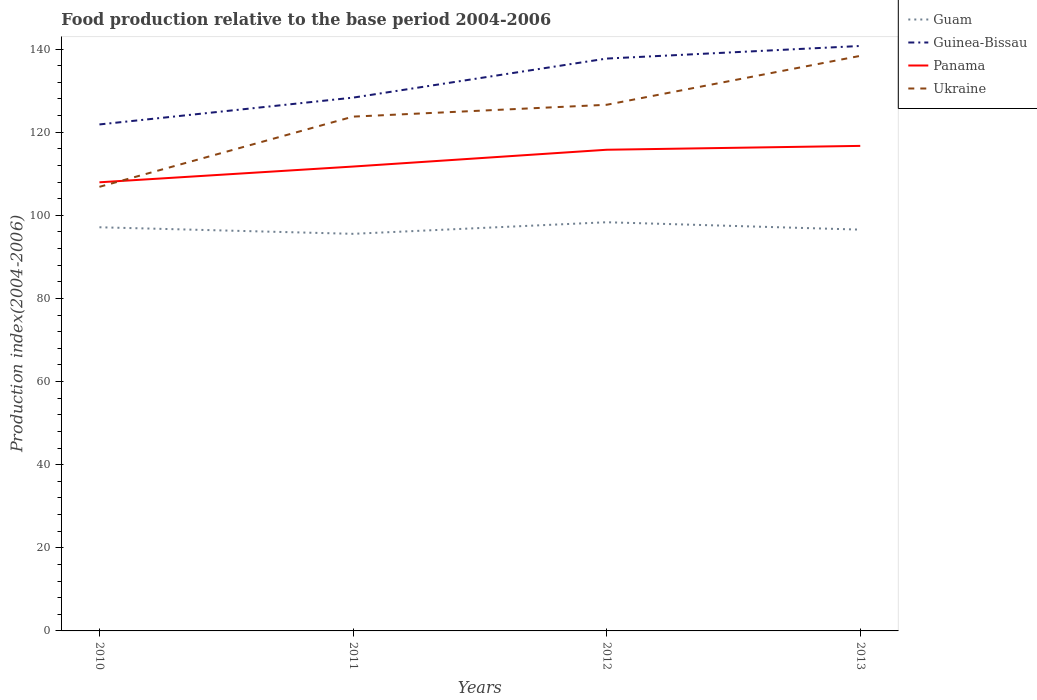Does the line corresponding to Guam intersect with the line corresponding to Ukraine?
Keep it short and to the point. No. Is the number of lines equal to the number of legend labels?
Your answer should be very brief. Yes. Across all years, what is the maximum food production index in Ukraine?
Provide a short and direct response. 106.85. What is the total food production index in Guam in the graph?
Your response must be concise. -2.79. What is the difference between the highest and the second highest food production index in Guam?
Provide a succinct answer. 2.79. What is the difference between the highest and the lowest food production index in Guinea-Bissau?
Your answer should be very brief. 2. How many years are there in the graph?
Provide a short and direct response. 4. What is the title of the graph?
Your response must be concise. Food production relative to the base period 2004-2006. Does "Kuwait" appear as one of the legend labels in the graph?
Give a very brief answer. No. What is the label or title of the X-axis?
Ensure brevity in your answer.  Years. What is the label or title of the Y-axis?
Your answer should be compact. Production index(2004-2006). What is the Production index(2004-2006) in Guam in 2010?
Offer a very short reply. 97.12. What is the Production index(2004-2006) of Guinea-Bissau in 2010?
Your answer should be compact. 121.86. What is the Production index(2004-2006) in Panama in 2010?
Provide a succinct answer. 107.94. What is the Production index(2004-2006) in Ukraine in 2010?
Provide a short and direct response. 106.85. What is the Production index(2004-2006) in Guam in 2011?
Make the answer very short. 95.54. What is the Production index(2004-2006) of Guinea-Bissau in 2011?
Your answer should be compact. 128.31. What is the Production index(2004-2006) of Panama in 2011?
Ensure brevity in your answer.  111.73. What is the Production index(2004-2006) of Ukraine in 2011?
Make the answer very short. 123.74. What is the Production index(2004-2006) of Guam in 2012?
Give a very brief answer. 98.33. What is the Production index(2004-2006) of Guinea-Bissau in 2012?
Provide a succinct answer. 137.71. What is the Production index(2004-2006) of Panama in 2012?
Make the answer very short. 115.77. What is the Production index(2004-2006) of Ukraine in 2012?
Offer a terse response. 126.59. What is the Production index(2004-2006) in Guam in 2013?
Offer a terse response. 96.55. What is the Production index(2004-2006) in Guinea-Bissau in 2013?
Your answer should be compact. 140.74. What is the Production index(2004-2006) of Panama in 2013?
Keep it short and to the point. 116.7. What is the Production index(2004-2006) of Ukraine in 2013?
Your response must be concise. 138.36. Across all years, what is the maximum Production index(2004-2006) in Guam?
Offer a very short reply. 98.33. Across all years, what is the maximum Production index(2004-2006) of Guinea-Bissau?
Keep it short and to the point. 140.74. Across all years, what is the maximum Production index(2004-2006) of Panama?
Your answer should be compact. 116.7. Across all years, what is the maximum Production index(2004-2006) in Ukraine?
Your answer should be very brief. 138.36. Across all years, what is the minimum Production index(2004-2006) in Guam?
Provide a short and direct response. 95.54. Across all years, what is the minimum Production index(2004-2006) of Guinea-Bissau?
Keep it short and to the point. 121.86. Across all years, what is the minimum Production index(2004-2006) in Panama?
Your response must be concise. 107.94. Across all years, what is the minimum Production index(2004-2006) in Ukraine?
Provide a succinct answer. 106.85. What is the total Production index(2004-2006) of Guam in the graph?
Offer a terse response. 387.54. What is the total Production index(2004-2006) of Guinea-Bissau in the graph?
Provide a succinct answer. 528.62. What is the total Production index(2004-2006) in Panama in the graph?
Your response must be concise. 452.14. What is the total Production index(2004-2006) in Ukraine in the graph?
Offer a very short reply. 495.54. What is the difference between the Production index(2004-2006) of Guam in 2010 and that in 2011?
Make the answer very short. 1.58. What is the difference between the Production index(2004-2006) in Guinea-Bissau in 2010 and that in 2011?
Offer a terse response. -6.45. What is the difference between the Production index(2004-2006) in Panama in 2010 and that in 2011?
Offer a terse response. -3.79. What is the difference between the Production index(2004-2006) of Ukraine in 2010 and that in 2011?
Offer a very short reply. -16.89. What is the difference between the Production index(2004-2006) of Guam in 2010 and that in 2012?
Provide a short and direct response. -1.21. What is the difference between the Production index(2004-2006) of Guinea-Bissau in 2010 and that in 2012?
Your answer should be very brief. -15.85. What is the difference between the Production index(2004-2006) of Panama in 2010 and that in 2012?
Ensure brevity in your answer.  -7.83. What is the difference between the Production index(2004-2006) in Ukraine in 2010 and that in 2012?
Keep it short and to the point. -19.74. What is the difference between the Production index(2004-2006) of Guam in 2010 and that in 2013?
Provide a succinct answer. 0.57. What is the difference between the Production index(2004-2006) of Guinea-Bissau in 2010 and that in 2013?
Your answer should be very brief. -18.88. What is the difference between the Production index(2004-2006) of Panama in 2010 and that in 2013?
Provide a succinct answer. -8.76. What is the difference between the Production index(2004-2006) of Ukraine in 2010 and that in 2013?
Keep it short and to the point. -31.51. What is the difference between the Production index(2004-2006) of Guam in 2011 and that in 2012?
Keep it short and to the point. -2.79. What is the difference between the Production index(2004-2006) in Guinea-Bissau in 2011 and that in 2012?
Give a very brief answer. -9.4. What is the difference between the Production index(2004-2006) in Panama in 2011 and that in 2012?
Offer a terse response. -4.04. What is the difference between the Production index(2004-2006) in Ukraine in 2011 and that in 2012?
Offer a very short reply. -2.85. What is the difference between the Production index(2004-2006) in Guam in 2011 and that in 2013?
Your response must be concise. -1.01. What is the difference between the Production index(2004-2006) in Guinea-Bissau in 2011 and that in 2013?
Your response must be concise. -12.43. What is the difference between the Production index(2004-2006) in Panama in 2011 and that in 2013?
Keep it short and to the point. -4.97. What is the difference between the Production index(2004-2006) in Ukraine in 2011 and that in 2013?
Your answer should be compact. -14.62. What is the difference between the Production index(2004-2006) in Guam in 2012 and that in 2013?
Your response must be concise. 1.78. What is the difference between the Production index(2004-2006) of Guinea-Bissau in 2012 and that in 2013?
Offer a very short reply. -3.03. What is the difference between the Production index(2004-2006) in Panama in 2012 and that in 2013?
Offer a very short reply. -0.93. What is the difference between the Production index(2004-2006) of Ukraine in 2012 and that in 2013?
Your answer should be compact. -11.77. What is the difference between the Production index(2004-2006) in Guam in 2010 and the Production index(2004-2006) in Guinea-Bissau in 2011?
Offer a terse response. -31.19. What is the difference between the Production index(2004-2006) in Guam in 2010 and the Production index(2004-2006) in Panama in 2011?
Offer a terse response. -14.61. What is the difference between the Production index(2004-2006) of Guam in 2010 and the Production index(2004-2006) of Ukraine in 2011?
Your answer should be very brief. -26.62. What is the difference between the Production index(2004-2006) of Guinea-Bissau in 2010 and the Production index(2004-2006) of Panama in 2011?
Give a very brief answer. 10.13. What is the difference between the Production index(2004-2006) of Guinea-Bissau in 2010 and the Production index(2004-2006) of Ukraine in 2011?
Provide a short and direct response. -1.88. What is the difference between the Production index(2004-2006) in Panama in 2010 and the Production index(2004-2006) in Ukraine in 2011?
Provide a succinct answer. -15.8. What is the difference between the Production index(2004-2006) of Guam in 2010 and the Production index(2004-2006) of Guinea-Bissau in 2012?
Give a very brief answer. -40.59. What is the difference between the Production index(2004-2006) in Guam in 2010 and the Production index(2004-2006) in Panama in 2012?
Your answer should be compact. -18.65. What is the difference between the Production index(2004-2006) in Guam in 2010 and the Production index(2004-2006) in Ukraine in 2012?
Give a very brief answer. -29.47. What is the difference between the Production index(2004-2006) in Guinea-Bissau in 2010 and the Production index(2004-2006) in Panama in 2012?
Offer a terse response. 6.09. What is the difference between the Production index(2004-2006) of Guinea-Bissau in 2010 and the Production index(2004-2006) of Ukraine in 2012?
Your response must be concise. -4.73. What is the difference between the Production index(2004-2006) in Panama in 2010 and the Production index(2004-2006) in Ukraine in 2012?
Your answer should be very brief. -18.65. What is the difference between the Production index(2004-2006) of Guam in 2010 and the Production index(2004-2006) of Guinea-Bissau in 2013?
Give a very brief answer. -43.62. What is the difference between the Production index(2004-2006) of Guam in 2010 and the Production index(2004-2006) of Panama in 2013?
Offer a terse response. -19.58. What is the difference between the Production index(2004-2006) of Guam in 2010 and the Production index(2004-2006) of Ukraine in 2013?
Make the answer very short. -41.24. What is the difference between the Production index(2004-2006) of Guinea-Bissau in 2010 and the Production index(2004-2006) of Panama in 2013?
Your response must be concise. 5.16. What is the difference between the Production index(2004-2006) of Guinea-Bissau in 2010 and the Production index(2004-2006) of Ukraine in 2013?
Provide a short and direct response. -16.5. What is the difference between the Production index(2004-2006) of Panama in 2010 and the Production index(2004-2006) of Ukraine in 2013?
Provide a succinct answer. -30.42. What is the difference between the Production index(2004-2006) of Guam in 2011 and the Production index(2004-2006) of Guinea-Bissau in 2012?
Ensure brevity in your answer.  -42.17. What is the difference between the Production index(2004-2006) of Guam in 2011 and the Production index(2004-2006) of Panama in 2012?
Provide a short and direct response. -20.23. What is the difference between the Production index(2004-2006) of Guam in 2011 and the Production index(2004-2006) of Ukraine in 2012?
Provide a succinct answer. -31.05. What is the difference between the Production index(2004-2006) of Guinea-Bissau in 2011 and the Production index(2004-2006) of Panama in 2012?
Keep it short and to the point. 12.54. What is the difference between the Production index(2004-2006) in Guinea-Bissau in 2011 and the Production index(2004-2006) in Ukraine in 2012?
Ensure brevity in your answer.  1.72. What is the difference between the Production index(2004-2006) of Panama in 2011 and the Production index(2004-2006) of Ukraine in 2012?
Your response must be concise. -14.86. What is the difference between the Production index(2004-2006) in Guam in 2011 and the Production index(2004-2006) in Guinea-Bissau in 2013?
Your answer should be compact. -45.2. What is the difference between the Production index(2004-2006) of Guam in 2011 and the Production index(2004-2006) of Panama in 2013?
Keep it short and to the point. -21.16. What is the difference between the Production index(2004-2006) of Guam in 2011 and the Production index(2004-2006) of Ukraine in 2013?
Give a very brief answer. -42.82. What is the difference between the Production index(2004-2006) in Guinea-Bissau in 2011 and the Production index(2004-2006) in Panama in 2013?
Your response must be concise. 11.61. What is the difference between the Production index(2004-2006) of Guinea-Bissau in 2011 and the Production index(2004-2006) of Ukraine in 2013?
Give a very brief answer. -10.05. What is the difference between the Production index(2004-2006) of Panama in 2011 and the Production index(2004-2006) of Ukraine in 2013?
Make the answer very short. -26.63. What is the difference between the Production index(2004-2006) in Guam in 2012 and the Production index(2004-2006) in Guinea-Bissau in 2013?
Offer a terse response. -42.41. What is the difference between the Production index(2004-2006) in Guam in 2012 and the Production index(2004-2006) in Panama in 2013?
Ensure brevity in your answer.  -18.37. What is the difference between the Production index(2004-2006) of Guam in 2012 and the Production index(2004-2006) of Ukraine in 2013?
Your answer should be very brief. -40.03. What is the difference between the Production index(2004-2006) in Guinea-Bissau in 2012 and the Production index(2004-2006) in Panama in 2013?
Your answer should be compact. 21.01. What is the difference between the Production index(2004-2006) of Guinea-Bissau in 2012 and the Production index(2004-2006) of Ukraine in 2013?
Offer a terse response. -0.65. What is the difference between the Production index(2004-2006) of Panama in 2012 and the Production index(2004-2006) of Ukraine in 2013?
Provide a succinct answer. -22.59. What is the average Production index(2004-2006) in Guam per year?
Your answer should be very brief. 96.89. What is the average Production index(2004-2006) in Guinea-Bissau per year?
Make the answer very short. 132.16. What is the average Production index(2004-2006) in Panama per year?
Provide a short and direct response. 113.03. What is the average Production index(2004-2006) in Ukraine per year?
Give a very brief answer. 123.89. In the year 2010, what is the difference between the Production index(2004-2006) in Guam and Production index(2004-2006) in Guinea-Bissau?
Provide a short and direct response. -24.74. In the year 2010, what is the difference between the Production index(2004-2006) of Guam and Production index(2004-2006) of Panama?
Provide a short and direct response. -10.82. In the year 2010, what is the difference between the Production index(2004-2006) of Guam and Production index(2004-2006) of Ukraine?
Provide a short and direct response. -9.73. In the year 2010, what is the difference between the Production index(2004-2006) in Guinea-Bissau and Production index(2004-2006) in Panama?
Offer a very short reply. 13.92. In the year 2010, what is the difference between the Production index(2004-2006) in Guinea-Bissau and Production index(2004-2006) in Ukraine?
Your answer should be compact. 15.01. In the year 2010, what is the difference between the Production index(2004-2006) in Panama and Production index(2004-2006) in Ukraine?
Offer a very short reply. 1.09. In the year 2011, what is the difference between the Production index(2004-2006) of Guam and Production index(2004-2006) of Guinea-Bissau?
Keep it short and to the point. -32.77. In the year 2011, what is the difference between the Production index(2004-2006) in Guam and Production index(2004-2006) in Panama?
Give a very brief answer. -16.19. In the year 2011, what is the difference between the Production index(2004-2006) in Guam and Production index(2004-2006) in Ukraine?
Give a very brief answer. -28.2. In the year 2011, what is the difference between the Production index(2004-2006) of Guinea-Bissau and Production index(2004-2006) of Panama?
Keep it short and to the point. 16.58. In the year 2011, what is the difference between the Production index(2004-2006) of Guinea-Bissau and Production index(2004-2006) of Ukraine?
Provide a short and direct response. 4.57. In the year 2011, what is the difference between the Production index(2004-2006) of Panama and Production index(2004-2006) of Ukraine?
Your response must be concise. -12.01. In the year 2012, what is the difference between the Production index(2004-2006) of Guam and Production index(2004-2006) of Guinea-Bissau?
Give a very brief answer. -39.38. In the year 2012, what is the difference between the Production index(2004-2006) in Guam and Production index(2004-2006) in Panama?
Offer a very short reply. -17.44. In the year 2012, what is the difference between the Production index(2004-2006) in Guam and Production index(2004-2006) in Ukraine?
Keep it short and to the point. -28.26. In the year 2012, what is the difference between the Production index(2004-2006) of Guinea-Bissau and Production index(2004-2006) of Panama?
Give a very brief answer. 21.94. In the year 2012, what is the difference between the Production index(2004-2006) of Guinea-Bissau and Production index(2004-2006) of Ukraine?
Provide a succinct answer. 11.12. In the year 2012, what is the difference between the Production index(2004-2006) of Panama and Production index(2004-2006) of Ukraine?
Your answer should be very brief. -10.82. In the year 2013, what is the difference between the Production index(2004-2006) in Guam and Production index(2004-2006) in Guinea-Bissau?
Keep it short and to the point. -44.19. In the year 2013, what is the difference between the Production index(2004-2006) in Guam and Production index(2004-2006) in Panama?
Provide a succinct answer. -20.15. In the year 2013, what is the difference between the Production index(2004-2006) in Guam and Production index(2004-2006) in Ukraine?
Make the answer very short. -41.81. In the year 2013, what is the difference between the Production index(2004-2006) in Guinea-Bissau and Production index(2004-2006) in Panama?
Offer a very short reply. 24.04. In the year 2013, what is the difference between the Production index(2004-2006) of Guinea-Bissau and Production index(2004-2006) of Ukraine?
Provide a succinct answer. 2.38. In the year 2013, what is the difference between the Production index(2004-2006) of Panama and Production index(2004-2006) of Ukraine?
Ensure brevity in your answer.  -21.66. What is the ratio of the Production index(2004-2006) of Guam in 2010 to that in 2011?
Your response must be concise. 1.02. What is the ratio of the Production index(2004-2006) of Guinea-Bissau in 2010 to that in 2011?
Keep it short and to the point. 0.95. What is the ratio of the Production index(2004-2006) in Panama in 2010 to that in 2011?
Make the answer very short. 0.97. What is the ratio of the Production index(2004-2006) of Ukraine in 2010 to that in 2011?
Give a very brief answer. 0.86. What is the ratio of the Production index(2004-2006) in Guinea-Bissau in 2010 to that in 2012?
Your response must be concise. 0.88. What is the ratio of the Production index(2004-2006) of Panama in 2010 to that in 2012?
Offer a terse response. 0.93. What is the ratio of the Production index(2004-2006) in Ukraine in 2010 to that in 2012?
Offer a terse response. 0.84. What is the ratio of the Production index(2004-2006) of Guam in 2010 to that in 2013?
Offer a very short reply. 1.01. What is the ratio of the Production index(2004-2006) of Guinea-Bissau in 2010 to that in 2013?
Offer a terse response. 0.87. What is the ratio of the Production index(2004-2006) of Panama in 2010 to that in 2013?
Your answer should be compact. 0.92. What is the ratio of the Production index(2004-2006) in Ukraine in 2010 to that in 2013?
Your answer should be compact. 0.77. What is the ratio of the Production index(2004-2006) in Guam in 2011 to that in 2012?
Give a very brief answer. 0.97. What is the ratio of the Production index(2004-2006) in Guinea-Bissau in 2011 to that in 2012?
Provide a succinct answer. 0.93. What is the ratio of the Production index(2004-2006) of Panama in 2011 to that in 2012?
Make the answer very short. 0.97. What is the ratio of the Production index(2004-2006) in Ukraine in 2011 to that in 2012?
Make the answer very short. 0.98. What is the ratio of the Production index(2004-2006) of Guam in 2011 to that in 2013?
Offer a terse response. 0.99. What is the ratio of the Production index(2004-2006) in Guinea-Bissau in 2011 to that in 2013?
Offer a very short reply. 0.91. What is the ratio of the Production index(2004-2006) in Panama in 2011 to that in 2013?
Your response must be concise. 0.96. What is the ratio of the Production index(2004-2006) of Ukraine in 2011 to that in 2013?
Offer a terse response. 0.89. What is the ratio of the Production index(2004-2006) of Guam in 2012 to that in 2013?
Provide a short and direct response. 1.02. What is the ratio of the Production index(2004-2006) of Guinea-Bissau in 2012 to that in 2013?
Your answer should be compact. 0.98. What is the ratio of the Production index(2004-2006) in Ukraine in 2012 to that in 2013?
Make the answer very short. 0.91. What is the difference between the highest and the second highest Production index(2004-2006) of Guam?
Provide a succinct answer. 1.21. What is the difference between the highest and the second highest Production index(2004-2006) in Guinea-Bissau?
Offer a very short reply. 3.03. What is the difference between the highest and the second highest Production index(2004-2006) of Ukraine?
Provide a succinct answer. 11.77. What is the difference between the highest and the lowest Production index(2004-2006) in Guam?
Provide a short and direct response. 2.79. What is the difference between the highest and the lowest Production index(2004-2006) in Guinea-Bissau?
Provide a succinct answer. 18.88. What is the difference between the highest and the lowest Production index(2004-2006) of Panama?
Provide a succinct answer. 8.76. What is the difference between the highest and the lowest Production index(2004-2006) of Ukraine?
Offer a terse response. 31.51. 